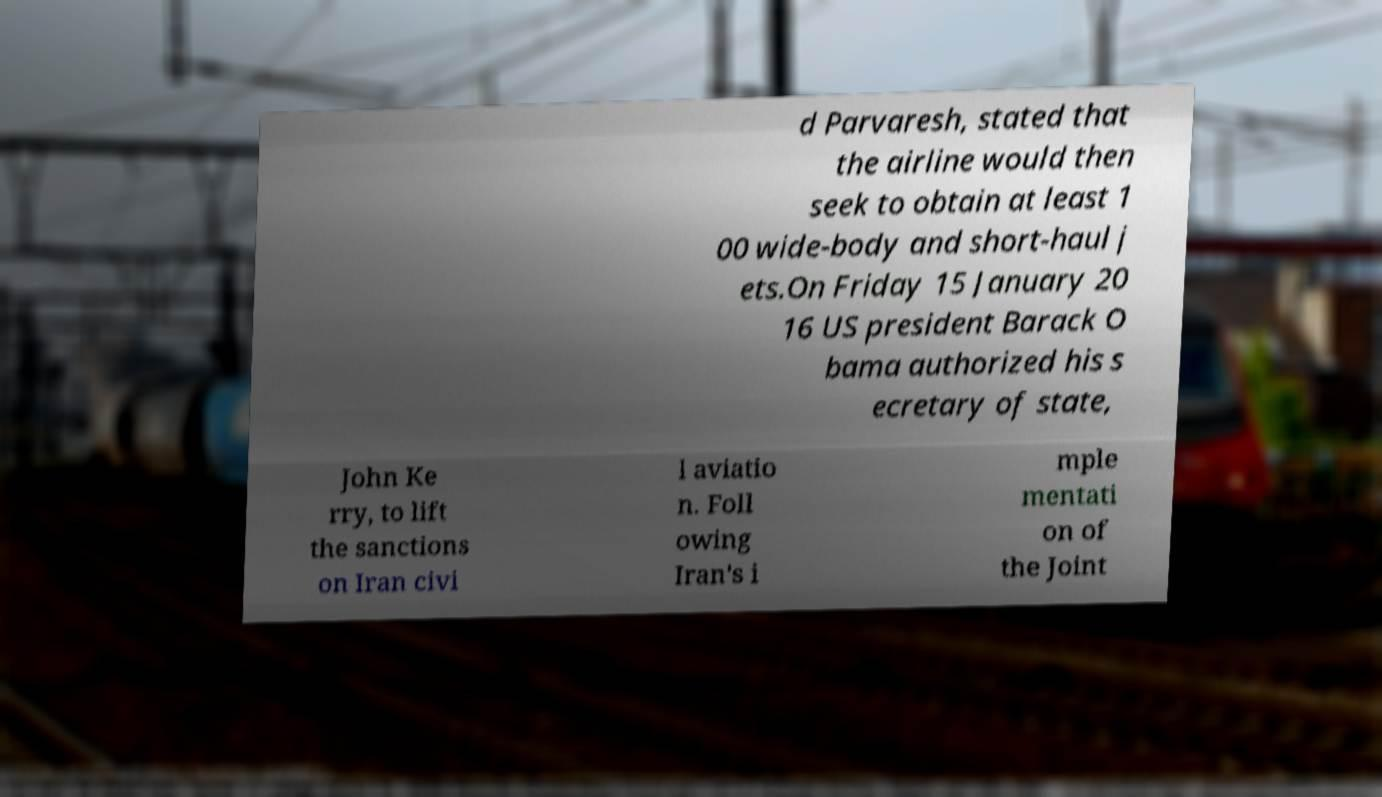Could you extract and type out the text from this image? d Parvaresh, stated that the airline would then seek to obtain at least 1 00 wide-body and short-haul j ets.On Friday 15 January 20 16 US president Barack O bama authorized his s ecretary of state, John Ke rry, to lift the sanctions on Iran civi l aviatio n. Foll owing Iran's i mple mentati on of the Joint 